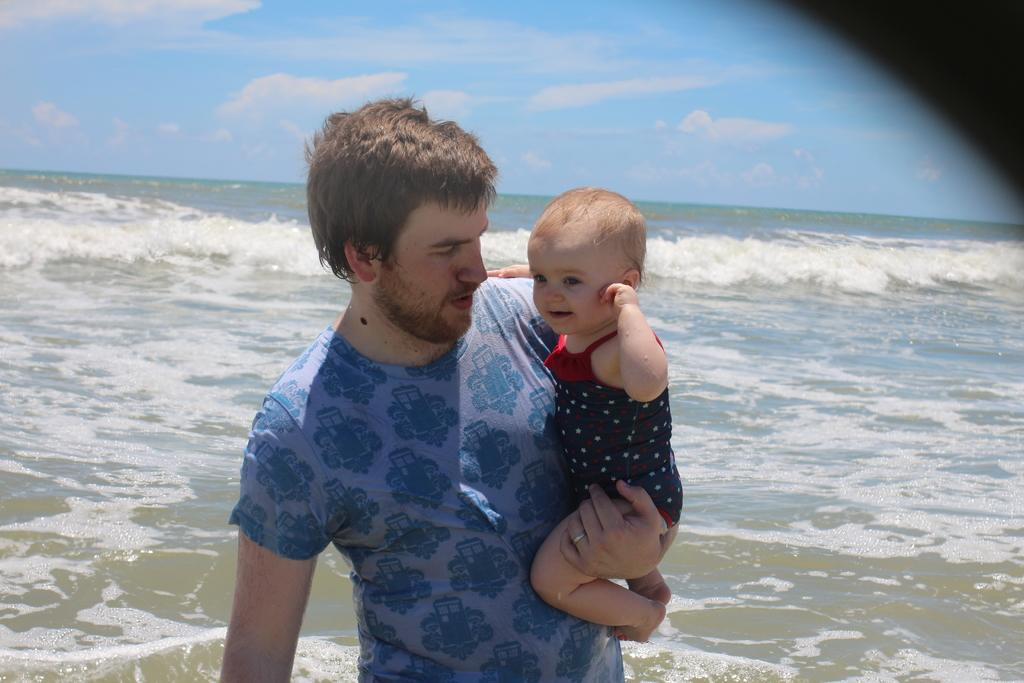What is the main subject of the image? There is a person in the image. What is the person wearing? The person is wearing a T-shirt. What is the person doing with their hand? The person is holding a baby with one hand. What can be seen in the background of the image? There are tides of the ocean and clouds in the blue sky in the background of the image. What type of shock can be seen affecting the person in the image? There is no shock present in the image; the person is simply holding a baby with one hand. What type of copper object is visible in the image? There is no copper object present in the image. 